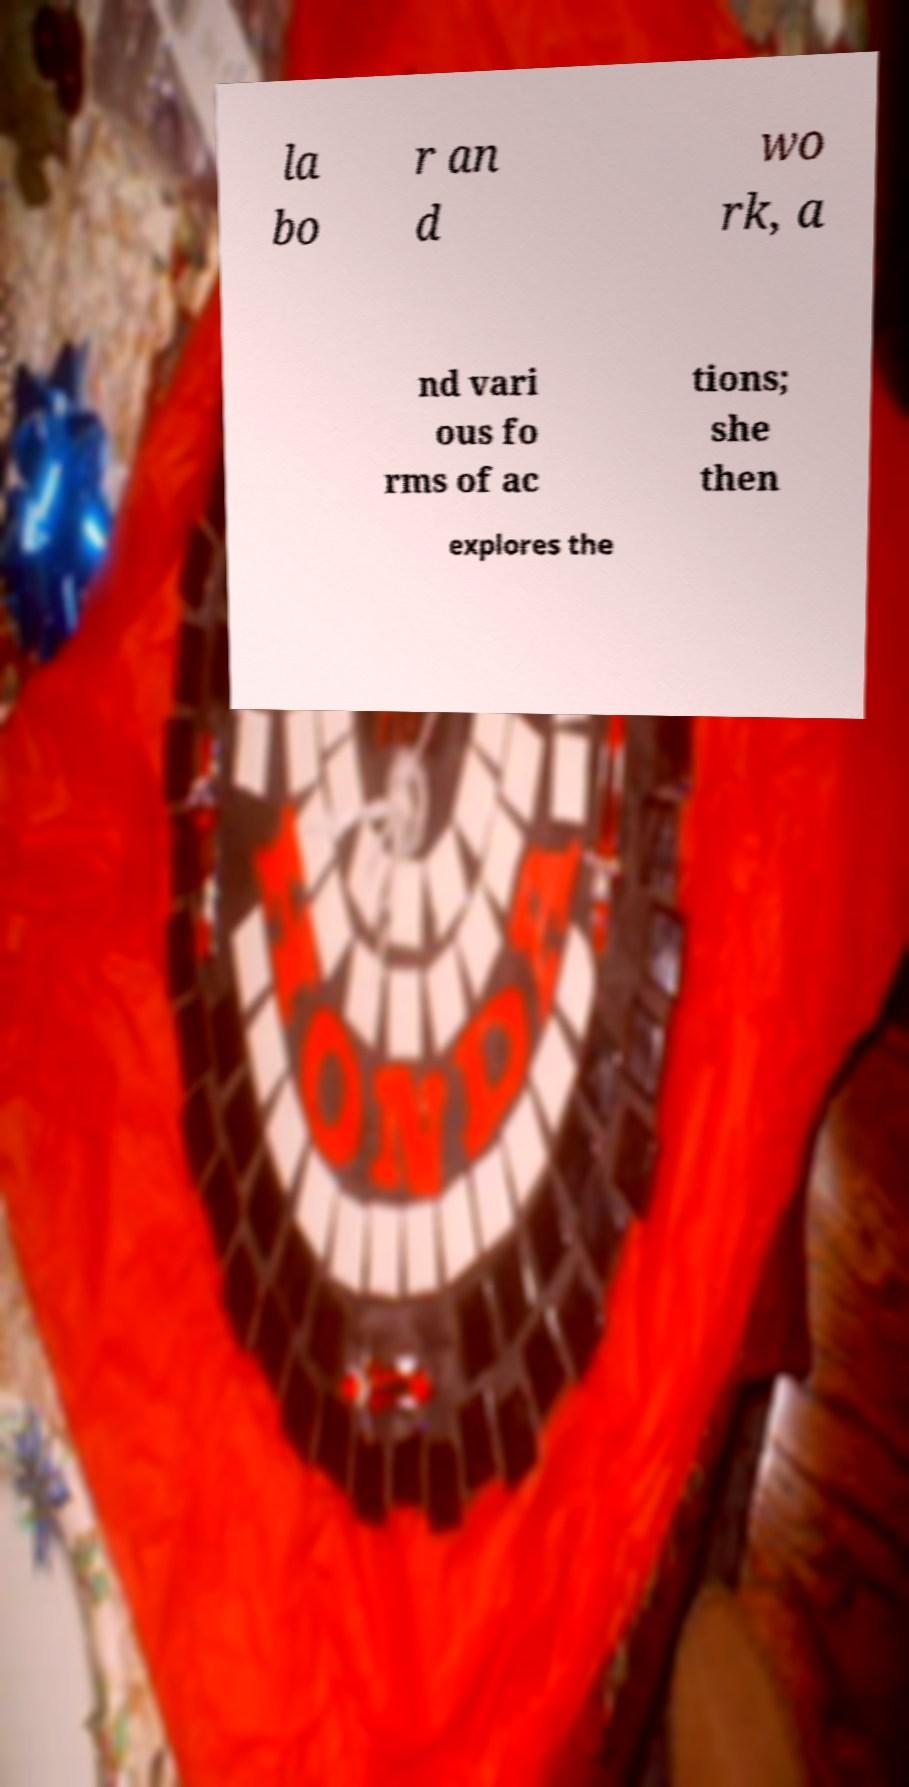For documentation purposes, I need the text within this image transcribed. Could you provide that? la bo r an d wo rk, a nd vari ous fo rms of ac tions; she then explores the 